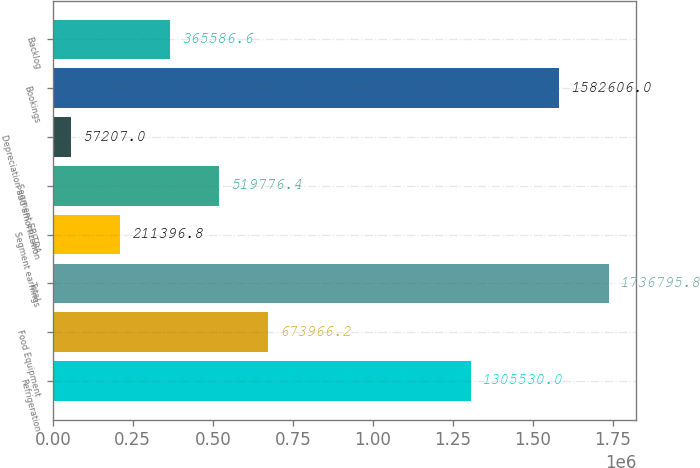Convert chart to OTSL. <chart><loc_0><loc_0><loc_500><loc_500><bar_chart><fcel>Refrigeration<fcel>Food Equipment<fcel>Total<fcel>Segment earnings<fcel>Segment EBITDA<fcel>Depreciation and amortization<fcel>Bookings<fcel>Backlog<nl><fcel>1.30553e+06<fcel>673966<fcel>1.7368e+06<fcel>211397<fcel>519776<fcel>57207<fcel>1.58261e+06<fcel>365587<nl></chart> 